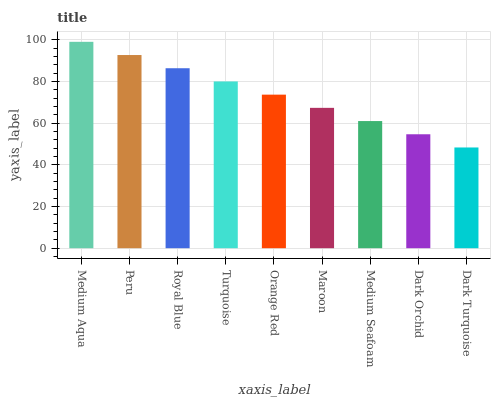Is Dark Turquoise the minimum?
Answer yes or no. Yes. Is Medium Aqua the maximum?
Answer yes or no. Yes. Is Peru the minimum?
Answer yes or no. No. Is Peru the maximum?
Answer yes or no. No. Is Medium Aqua greater than Peru?
Answer yes or no. Yes. Is Peru less than Medium Aqua?
Answer yes or no. Yes. Is Peru greater than Medium Aqua?
Answer yes or no. No. Is Medium Aqua less than Peru?
Answer yes or no. No. Is Orange Red the high median?
Answer yes or no. Yes. Is Orange Red the low median?
Answer yes or no. Yes. Is Dark Orchid the high median?
Answer yes or no. No. Is Peru the low median?
Answer yes or no. No. 